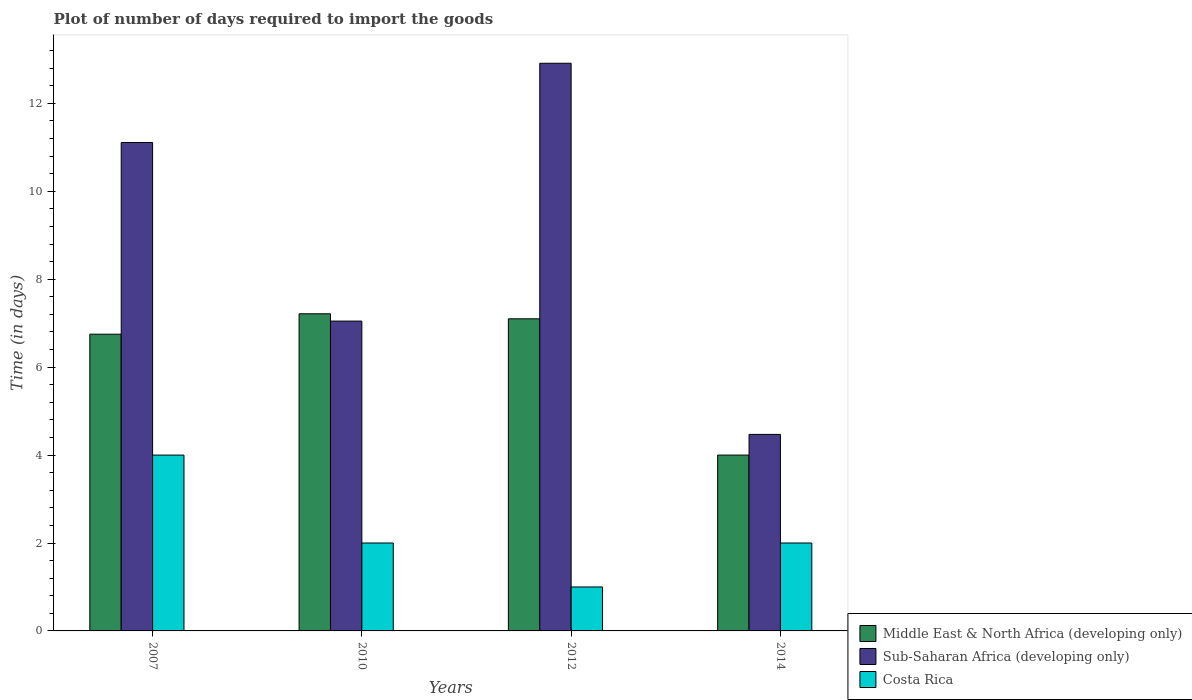How many groups of bars are there?
Offer a very short reply. 4. Are the number of bars per tick equal to the number of legend labels?
Provide a short and direct response. Yes. Are the number of bars on each tick of the X-axis equal?
Provide a short and direct response. Yes. What is the time required to import goods in Sub-Saharan Africa (developing only) in 2010?
Your answer should be very brief. 7.05. Across all years, what is the maximum time required to import goods in Costa Rica?
Provide a short and direct response. 4. Across all years, what is the minimum time required to import goods in Costa Rica?
Give a very brief answer. 1. In which year was the time required to import goods in Sub-Saharan Africa (developing only) maximum?
Make the answer very short. 2012. What is the total time required to import goods in Sub-Saharan Africa (developing only) in the graph?
Provide a succinct answer. 35.54. What is the difference between the time required to import goods in Sub-Saharan Africa (developing only) in 2010 and that in 2014?
Your response must be concise. 2.58. What is the difference between the time required to import goods in Sub-Saharan Africa (developing only) in 2010 and the time required to import goods in Costa Rica in 2012?
Make the answer very short. 6.05. What is the average time required to import goods in Costa Rica per year?
Ensure brevity in your answer.  2.25. In the year 2007, what is the difference between the time required to import goods in Sub-Saharan Africa (developing only) and time required to import goods in Middle East & North Africa (developing only)?
Provide a short and direct response. 4.36. In how many years, is the time required to import goods in Costa Rica greater than 12.4 days?
Your answer should be very brief. 0. What is the ratio of the time required to import goods in Costa Rica in 2012 to that in 2014?
Give a very brief answer. 0.5. Is the time required to import goods in Sub-Saharan Africa (developing only) in 2007 less than that in 2012?
Keep it short and to the point. Yes. Is the difference between the time required to import goods in Sub-Saharan Africa (developing only) in 2010 and 2012 greater than the difference between the time required to import goods in Middle East & North Africa (developing only) in 2010 and 2012?
Your answer should be compact. No. What is the difference between the highest and the second highest time required to import goods in Middle East & North Africa (developing only)?
Provide a short and direct response. 0.11. What is the difference between the highest and the lowest time required to import goods in Sub-Saharan Africa (developing only)?
Keep it short and to the point. 8.44. Is the sum of the time required to import goods in Costa Rica in 2012 and 2014 greater than the maximum time required to import goods in Middle East & North Africa (developing only) across all years?
Your response must be concise. No. How many years are there in the graph?
Ensure brevity in your answer.  4. Where does the legend appear in the graph?
Provide a succinct answer. Bottom right. How many legend labels are there?
Offer a very short reply. 3. What is the title of the graph?
Keep it short and to the point. Plot of number of days required to import the goods. Does "Kyrgyz Republic" appear as one of the legend labels in the graph?
Provide a succinct answer. No. What is the label or title of the Y-axis?
Your answer should be very brief. Time (in days). What is the Time (in days) in Middle East & North Africa (developing only) in 2007?
Provide a short and direct response. 6.75. What is the Time (in days) of Sub-Saharan Africa (developing only) in 2007?
Give a very brief answer. 11.11. What is the Time (in days) in Middle East & North Africa (developing only) in 2010?
Provide a short and direct response. 7.21. What is the Time (in days) in Sub-Saharan Africa (developing only) in 2010?
Your answer should be very brief. 7.05. What is the Time (in days) in Sub-Saharan Africa (developing only) in 2012?
Ensure brevity in your answer.  12.91. What is the Time (in days) of Costa Rica in 2012?
Give a very brief answer. 1. What is the Time (in days) in Sub-Saharan Africa (developing only) in 2014?
Your response must be concise. 4.47. What is the Time (in days) in Costa Rica in 2014?
Your answer should be very brief. 2. Across all years, what is the maximum Time (in days) in Middle East & North Africa (developing only)?
Offer a very short reply. 7.21. Across all years, what is the maximum Time (in days) in Sub-Saharan Africa (developing only)?
Offer a very short reply. 12.91. Across all years, what is the maximum Time (in days) in Costa Rica?
Your answer should be very brief. 4. Across all years, what is the minimum Time (in days) of Sub-Saharan Africa (developing only)?
Keep it short and to the point. 4.47. What is the total Time (in days) in Middle East & North Africa (developing only) in the graph?
Ensure brevity in your answer.  25.06. What is the total Time (in days) of Sub-Saharan Africa (developing only) in the graph?
Offer a terse response. 35.54. What is the difference between the Time (in days) of Middle East & North Africa (developing only) in 2007 and that in 2010?
Your response must be concise. -0.46. What is the difference between the Time (in days) of Sub-Saharan Africa (developing only) in 2007 and that in 2010?
Keep it short and to the point. 4.06. What is the difference between the Time (in days) in Middle East & North Africa (developing only) in 2007 and that in 2012?
Offer a terse response. -0.35. What is the difference between the Time (in days) in Sub-Saharan Africa (developing only) in 2007 and that in 2012?
Your answer should be compact. -1.8. What is the difference between the Time (in days) in Costa Rica in 2007 and that in 2012?
Ensure brevity in your answer.  3. What is the difference between the Time (in days) in Middle East & North Africa (developing only) in 2007 and that in 2014?
Give a very brief answer. 2.75. What is the difference between the Time (in days) in Sub-Saharan Africa (developing only) in 2007 and that in 2014?
Give a very brief answer. 6.64. What is the difference between the Time (in days) in Costa Rica in 2007 and that in 2014?
Your answer should be compact. 2. What is the difference between the Time (in days) in Middle East & North Africa (developing only) in 2010 and that in 2012?
Provide a short and direct response. 0.11. What is the difference between the Time (in days) of Sub-Saharan Africa (developing only) in 2010 and that in 2012?
Provide a short and direct response. -5.86. What is the difference between the Time (in days) in Middle East & North Africa (developing only) in 2010 and that in 2014?
Your answer should be compact. 3.21. What is the difference between the Time (in days) in Sub-Saharan Africa (developing only) in 2010 and that in 2014?
Offer a very short reply. 2.58. What is the difference between the Time (in days) of Sub-Saharan Africa (developing only) in 2012 and that in 2014?
Offer a terse response. 8.44. What is the difference between the Time (in days) of Costa Rica in 2012 and that in 2014?
Your answer should be very brief. -1. What is the difference between the Time (in days) of Middle East & North Africa (developing only) in 2007 and the Time (in days) of Sub-Saharan Africa (developing only) in 2010?
Your response must be concise. -0.3. What is the difference between the Time (in days) in Middle East & North Africa (developing only) in 2007 and the Time (in days) in Costa Rica in 2010?
Give a very brief answer. 4.75. What is the difference between the Time (in days) in Sub-Saharan Africa (developing only) in 2007 and the Time (in days) in Costa Rica in 2010?
Offer a very short reply. 9.11. What is the difference between the Time (in days) of Middle East & North Africa (developing only) in 2007 and the Time (in days) of Sub-Saharan Africa (developing only) in 2012?
Ensure brevity in your answer.  -6.16. What is the difference between the Time (in days) of Middle East & North Africa (developing only) in 2007 and the Time (in days) of Costa Rica in 2012?
Provide a short and direct response. 5.75. What is the difference between the Time (in days) in Sub-Saharan Africa (developing only) in 2007 and the Time (in days) in Costa Rica in 2012?
Your answer should be very brief. 10.11. What is the difference between the Time (in days) in Middle East & North Africa (developing only) in 2007 and the Time (in days) in Sub-Saharan Africa (developing only) in 2014?
Your answer should be very brief. 2.28. What is the difference between the Time (in days) in Middle East & North Africa (developing only) in 2007 and the Time (in days) in Costa Rica in 2014?
Offer a terse response. 4.75. What is the difference between the Time (in days) in Sub-Saharan Africa (developing only) in 2007 and the Time (in days) in Costa Rica in 2014?
Provide a succinct answer. 9.11. What is the difference between the Time (in days) of Middle East & North Africa (developing only) in 2010 and the Time (in days) of Sub-Saharan Africa (developing only) in 2012?
Provide a short and direct response. -5.7. What is the difference between the Time (in days) in Middle East & North Africa (developing only) in 2010 and the Time (in days) in Costa Rica in 2012?
Give a very brief answer. 6.21. What is the difference between the Time (in days) in Sub-Saharan Africa (developing only) in 2010 and the Time (in days) in Costa Rica in 2012?
Provide a short and direct response. 6.05. What is the difference between the Time (in days) of Middle East & North Africa (developing only) in 2010 and the Time (in days) of Sub-Saharan Africa (developing only) in 2014?
Give a very brief answer. 2.74. What is the difference between the Time (in days) in Middle East & North Africa (developing only) in 2010 and the Time (in days) in Costa Rica in 2014?
Your response must be concise. 5.21. What is the difference between the Time (in days) of Sub-Saharan Africa (developing only) in 2010 and the Time (in days) of Costa Rica in 2014?
Provide a succinct answer. 5.05. What is the difference between the Time (in days) in Middle East & North Africa (developing only) in 2012 and the Time (in days) in Sub-Saharan Africa (developing only) in 2014?
Give a very brief answer. 2.63. What is the difference between the Time (in days) in Sub-Saharan Africa (developing only) in 2012 and the Time (in days) in Costa Rica in 2014?
Give a very brief answer. 10.91. What is the average Time (in days) in Middle East & North Africa (developing only) per year?
Your answer should be compact. 6.27. What is the average Time (in days) in Sub-Saharan Africa (developing only) per year?
Your answer should be very brief. 8.89. What is the average Time (in days) in Costa Rica per year?
Provide a succinct answer. 2.25. In the year 2007, what is the difference between the Time (in days) of Middle East & North Africa (developing only) and Time (in days) of Sub-Saharan Africa (developing only)?
Offer a terse response. -4.36. In the year 2007, what is the difference between the Time (in days) of Middle East & North Africa (developing only) and Time (in days) of Costa Rica?
Your response must be concise. 2.75. In the year 2007, what is the difference between the Time (in days) of Sub-Saharan Africa (developing only) and Time (in days) of Costa Rica?
Your response must be concise. 7.11. In the year 2010, what is the difference between the Time (in days) of Middle East & North Africa (developing only) and Time (in days) of Sub-Saharan Africa (developing only)?
Your response must be concise. 0.17. In the year 2010, what is the difference between the Time (in days) in Middle East & North Africa (developing only) and Time (in days) in Costa Rica?
Your answer should be very brief. 5.21. In the year 2010, what is the difference between the Time (in days) of Sub-Saharan Africa (developing only) and Time (in days) of Costa Rica?
Keep it short and to the point. 5.05. In the year 2012, what is the difference between the Time (in days) of Middle East & North Africa (developing only) and Time (in days) of Sub-Saharan Africa (developing only)?
Offer a terse response. -5.81. In the year 2012, what is the difference between the Time (in days) of Sub-Saharan Africa (developing only) and Time (in days) of Costa Rica?
Give a very brief answer. 11.91. In the year 2014, what is the difference between the Time (in days) in Middle East & North Africa (developing only) and Time (in days) in Sub-Saharan Africa (developing only)?
Ensure brevity in your answer.  -0.47. In the year 2014, what is the difference between the Time (in days) in Sub-Saharan Africa (developing only) and Time (in days) in Costa Rica?
Give a very brief answer. 2.47. What is the ratio of the Time (in days) in Middle East & North Africa (developing only) in 2007 to that in 2010?
Ensure brevity in your answer.  0.94. What is the ratio of the Time (in days) in Sub-Saharan Africa (developing only) in 2007 to that in 2010?
Provide a succinct answer. 1.58. What is the ratio of the Time (in days) of Costa Rica in 2007 to that in 2010?
Ensure brevity in your answer.  2. What is the ratio of the Time (in days) in Middle East & North Africa (developing only) in 2007 to that in 2012?
Offer a very short reply. 0.95. What is the ratio of the Time (in days) of Sub-Saharan Africa (developing only) in 2007 to that in 2012?
Your answer should be compact. 0.86. What is the ratio of the Time (in days) in Costa Rica in 2007 to that in 2012?
Provide a succinct answer. 4. What is the ratio of the Time (in days) of Middle East & North Africa (developing only) in 2007 to that in 2014?
Your response must be concise. 1.69. What is the ratio of the Time (in days) of Sub-Saharan Africa (developing only) in 2007 to that in 2014?
Your response must be concise. 2.49. What is the ratio of the Time (in days) of Costa Rica in 2007 to that in 2014?
Make the answer very short. 2. What is the ratio of the Time (in days) in Middle East & North Africa (developing only) in 2010 to that in 2012?
Give a very brief answer. 1.02. What is the ratio of the Time (in days) of Sub-Saharan Africa (developing only) in 2010 to that in 2012?
Offer a very short reply. 0.55. What is the ratio of the Time (in days) of Middle East & North Africa (developing only) in 2010 to that in 2014?
Your answer should be very brief. 1.8. What is the ratio of the Time (in days) of Sub-Saharan Africa (developing only) in 2010 to that in 2014?
Your response must be concise. 1.58. What is the ratio of the Time (in days) of Costa Rica in 2010 to that in 2014?
Give a very brief answer. 1. What is the ratio of the Time (in days) of Middle East & North Africa (developing only) in 2012 to that in 2014?
Provide a succinct answer. 1.77. What is the ratio of the Time (in days) in Sub-Saharan Africa (developing only) in 2012 to that in 2014?
Your answer should be very brief. 2.89. What is the ratio of the Time (in days) of Costa Rica in 2012 to that in 2014?
Offer a very short reply. 0.5. What is the difference between the highest and the second highest Time (in days) of Middle East & North Africa (developing only)?
Your response must be concise. 0.11. What is the difference between the highest and the second highest Time (in days) in Sub-Saharan Africa (developing only)?
Make the answer very short. 1.8. What is the difference between the highest and the lowest Time (in days) in Middle East & North Africa (developing only)?
Ensure brevity in your answer.  3.21. What is the difference between the highest and the lowest Time (in days) of Sub-Saharan Africa (developing only)?
Give a very brief answer. 8.44. What is the difference between the highest and the lowest Time (in days) in Costa Rica?
Offer a terse response. 3. 